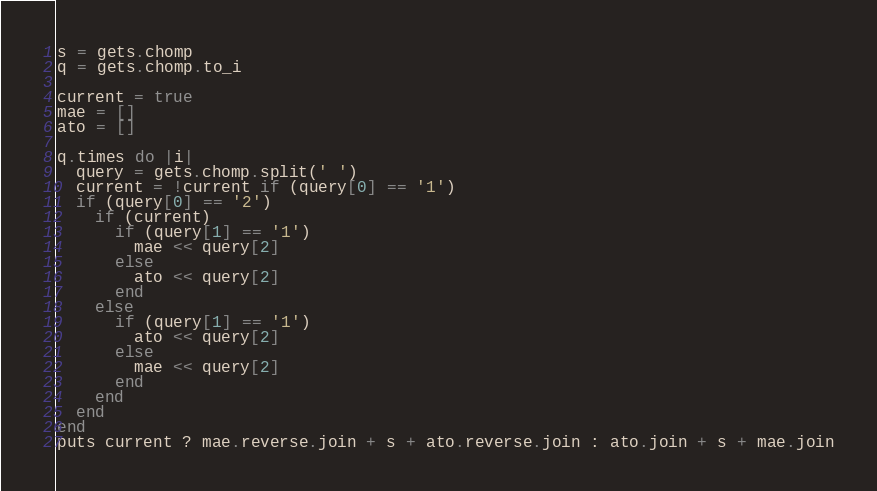<code> <loc_0><loc_0><loc_500><loc_500><_Ruby_>s = gets.chomp
q = gets.chomp.to_i

current = true
mae = []
ato = []

q.times do |i|
  query = gets.chomp.split(' ')
  current = !current if (query[0] == '1')
  if (query[0] == '2')
    if (current)
      if (query[1] == '1')
        mae << query[2]
      else
        ato << query[2]
      end
    else
      if (query[1] == '1')
        ato << query[2]
      else
        mae << query[2]
      end
    end
  end
end
puts current ? mae.reverse.join + s + ato.reverse.join : ato.join + s + mae.join</code> 